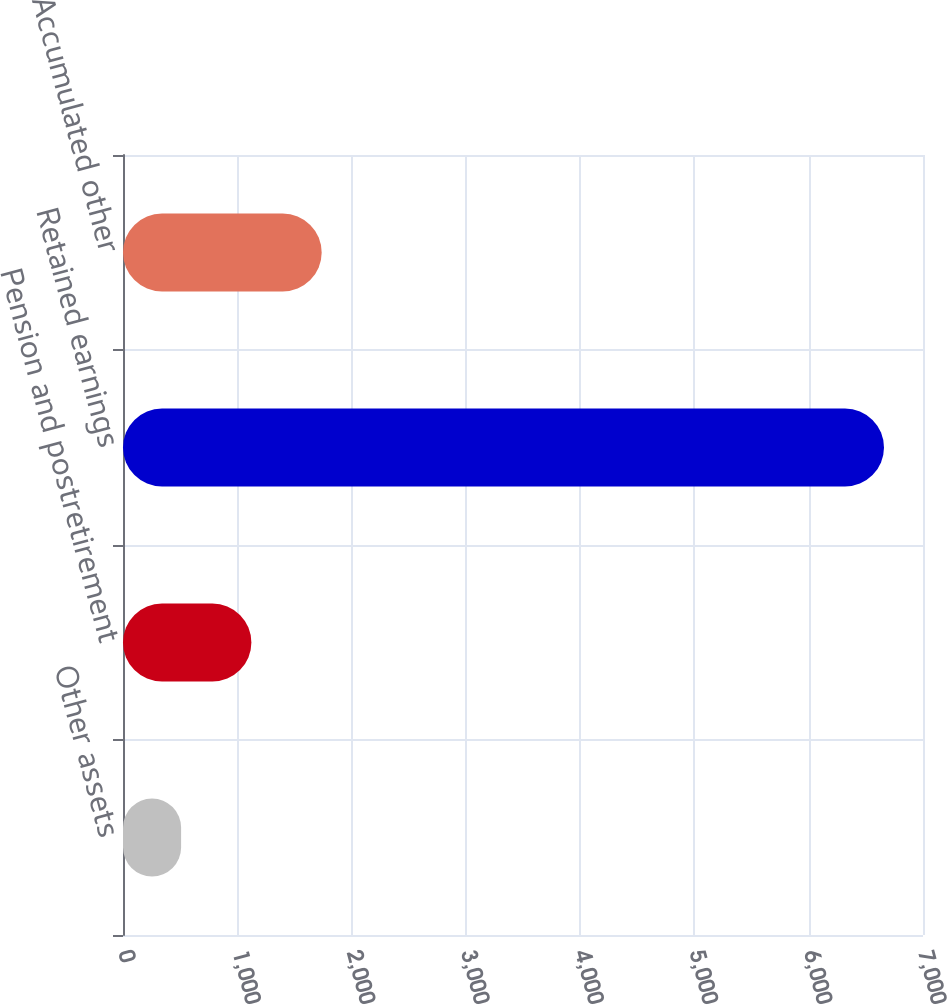<chart> <loc_0><loc_0><loc_500><loc_500><bar_chart><fcel>Other assets<fcel>Pension and postretirement<fcel>Retained earnings<fcel>Accumulated other<nl><fcel>508.4<fcel>1123.43<fcel>6658.7<fcel>1738.46<nl></chart> 